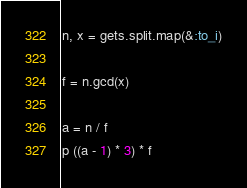Convert code to text. <code><loc_0><loc_0><loc_500><loc_500><_Ruby_>n, x = gets.split.map(&:to_i)

f = n.gcd(x)

a = n / f
p ((a - 1) * 3) * f</code> 